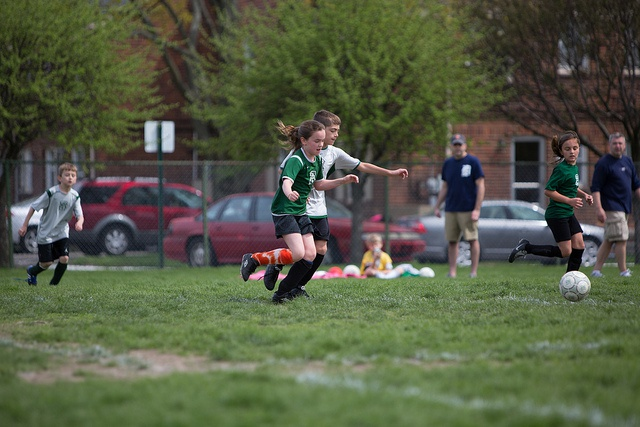Describe the objects in this image and their specific colors. I can see people in darkgreen, black, gray, and teal tones, car in darkgreen, gray, purple, and black tones, car in darkgreen, black, purple, and gray tones, people in darkgreen, black, gray, maroon, and brown tones, and people in darkgreen, black, gray, and darkgray tones in this image. 